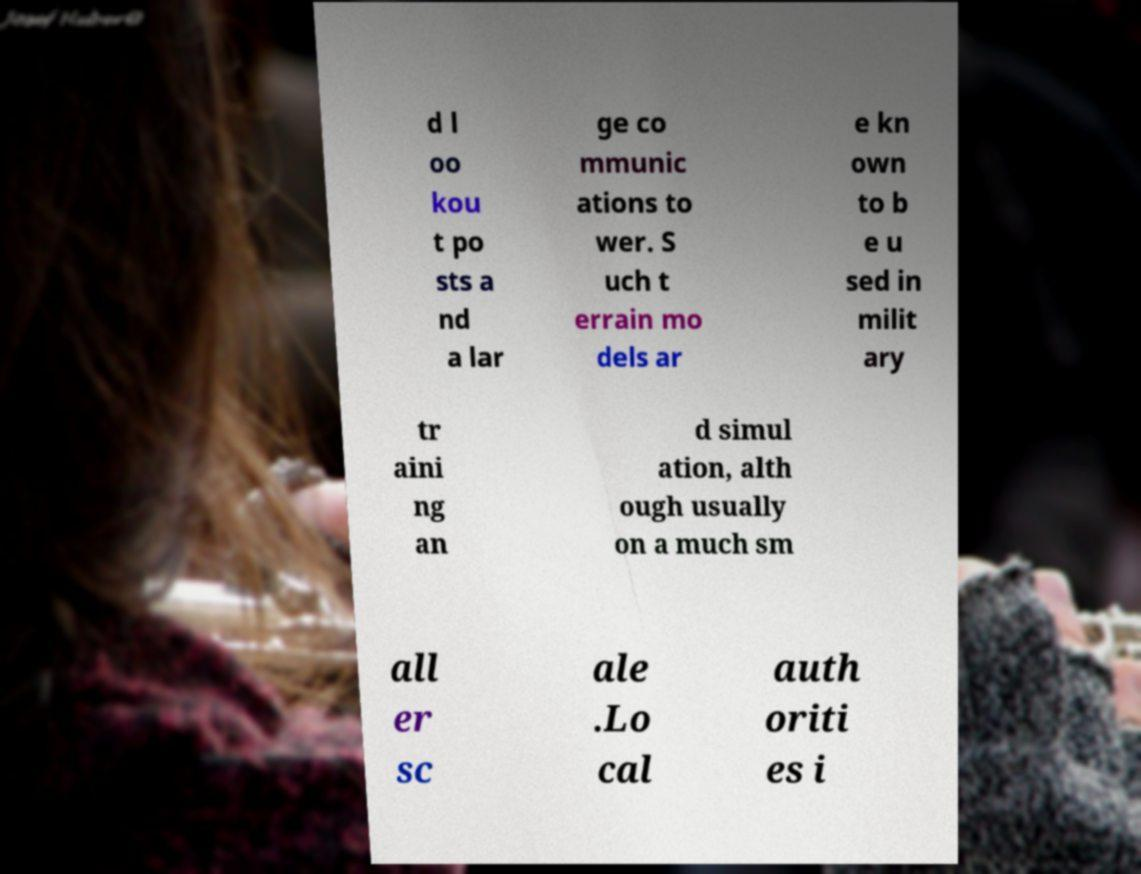There's text embedded in this image that I need extracted. Can you transcribe it verbatim? d l oo kou t po sts a nd a lar ge co mmunic ations to wer. S uch t errain mo dels ar e kn own to b e u sed in milit ary tr aini ng an d simul ation, alth ough usually on a much sm all er sc ale .Lo cal auth oriti es i 